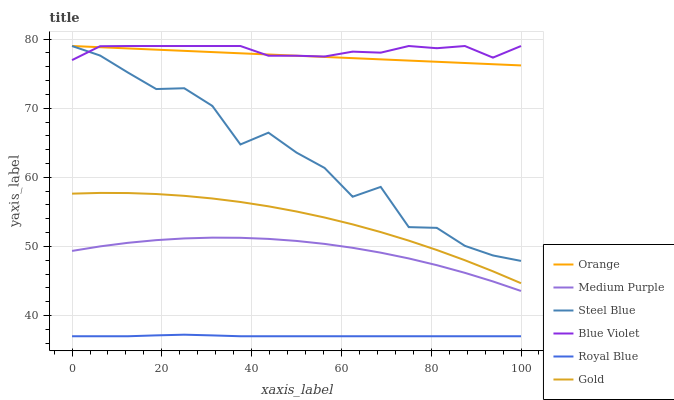Does Royal Blue have the minimum area under the curve?
Answer yes or no. Yes. Does Blue Violet have the maximum area under the curve?
Answer yes or no. Yes. Does Steel Blue have the minimum area under the curve?
Answer yes or no. No. Does Steel Blue have the maximum area under the curve?
Answer yes or no. No. Is Orange the smoothest?
Answer yes or no. Yes. Is Steel Blue the roughest?
Answer yes or no. Yes. Is Medium Purple the smoothest?
Answer yes or no. No. Is Medium Purple the roughest?
Answer yes or no. No. Does Royal Blue have the lowest value?
Answer yes or no. Yes. Does Steel Blue have the lowest value?
Answer yes or no. No. Does Blue Violet have the highest value?
Answer yes or no. Yes. Does Medium Purple have the highest value?
Answer yes or no. No. Is Gold less than Blue Violet?
Answer yes or no. Yes. Is Orange greater than Royal Blue?
Answer yes or no. Yes. Does Steel Blue intersect Orange?
Answer yes or no. Yes. Is Steel Blue less than Orange?
Answer yes or no. No. Is Steel Blue greater than Orange?
Answer yes or no. No. Does Gold intersect Blue Violet?
Answer yes or no. No. 